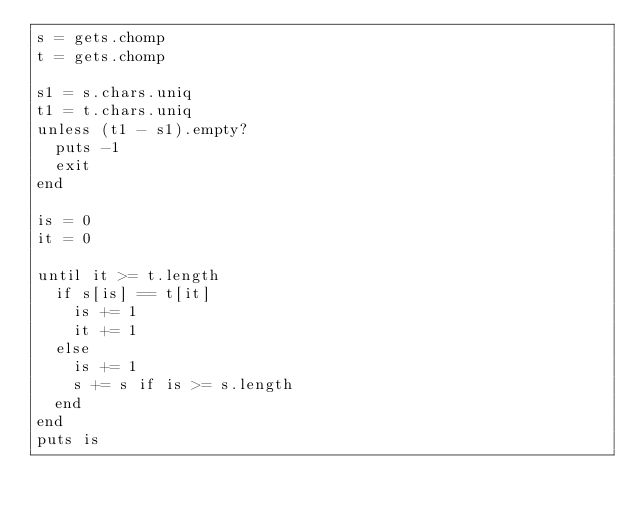<code> <loc_0><loc_0><loc_500><loc_500><_Ruby_>s = gets.chomp
t = gets.chomp

s1 = s.chars.uniq
t1 = t.chars.uniq
unless (t1 - s1).empty?
  puts -1
  exit
end

is = 0
it = 0

until it >= t.length
  if s[is] == t[it]
    is += 1
    it += 1
  else
    is += 1
    s += s if is >= s.length
  end
end
puts is</code> 